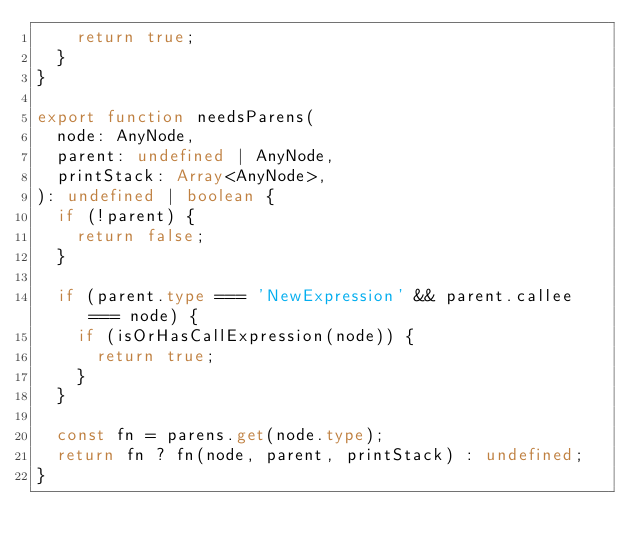<code> <loc_0><loc_0><loc_500><loc_500><_TypeScript_>    return true;
  }
}

export function needsParens(
  node: AnyNode,
  parent: undefined | AnyNode,
  printStack: Array<AnyNode>,
): undefined | boolean {
  if (!parent) {
    return false;
  }

  if (parent.type === 'NewExpression' && parent.callee === node) {
    if (isOrHasCallExpression(node)) {
      return true;
    }
  }

  const fn = parens.get(node.type);
  return fn ? fn(node, parent, printStack) : undefined;
}
</code> 